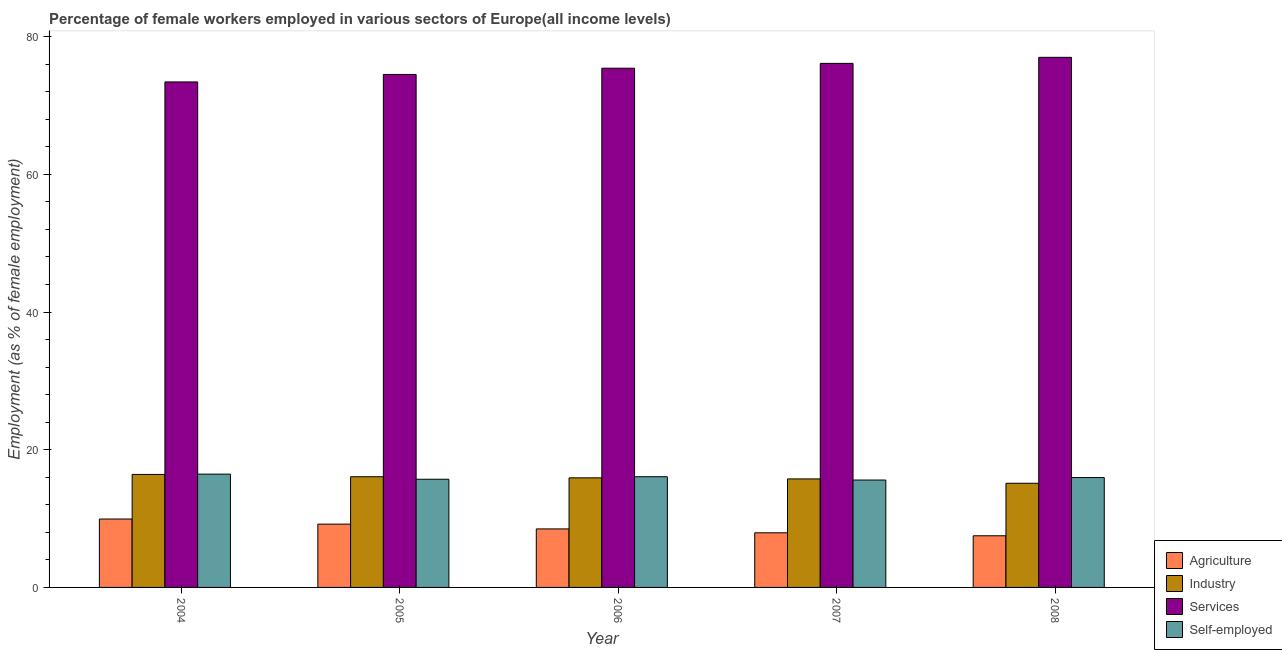How many different coloured bars are there?
Your answer should be compact. 4. How many groups of bars are there?
Provide a short and direct response. 5. Are the number of bars per tick equal to the number of legend labels?
Offer a terse response. Yes. Are the number of bars on each tick of the X-axis equal?
Ensure brevity in your answer.  Yes. What is the percentage of self employed female workers in 2006?
Provide a succinct answer. 16.08. Across all years, what is the maximum percentage of female workers in industry?
Provide a short and direct response. 16.41. Across all years, what is the minimum percentage of female workers in agriculture?
Provide a short and direct response. 7.5. In which year was the percentage of female workers in industry minimum?
Your response must be concise. 2008. What is the total percentage of female workers in agriculture in the graph?
Provide a succinct answer. 43.07. What is the difference between the percentage of self employed female workers in 2004 and that in 2005?
Keep it short and to the point. 0.74. What is the difference between the percentage of female workers in industry in 2005 and the percentage of female workers in agriculture in 2007?
Offer a very short reply. 0.32. What is the average percentage of female workers in agriculture per year?
Offer a terse response. 8.61. In how many years, is the percentage of self employed female workers greater than 40 %?
Your response must be concise. 0. What is the ratio of the percentage of female workers in industry in 2004 to that in 2005?
Ensure brevity in your answer.  1.02. Is the difference between the percentage of female workers in industry in 2005 and 2007 greater than the difference between the percentage of self employed female workers in 2005 and 2007?
Offer a terse response. No. What is the difference between the highest and the second highest percentage of female workers in services?
Ensure brevity in your answer.  0.88. What is the difference between the highest and the lowest percentage of female workers in agriculture?
Offer a terse response. 2.43. What does the 2nd bar from the left in 2008 represents?
Provide a succinct answer. Industry. What does the 2nd bar from the right in 2006 represents?
Provide a succinct answer. Services. Are all the bars in the graph horizontal?
Provide a short and direct response. No. How many years are there in the graph?
Keep it short and to the point. 5. What is the title of the graph?
Your response must be concise. Percentage of female workers employed in various sectors of Europe(all income levels). Does "Taxes on goods and services" appear as one of the legend labels in the graph?
Make the answer very short. No. What is the label or title of the Y-axis?
Provide a succinct answer. Employment (as % of female employment). What is the Employment (as % of female employment) in Agriculture in 2004?
Ensure brevity in your answer.  9.94. What is the Employment (as % of female employment) of Industry in 2004?
Your answer should be compact. 16.41. What is the Employment (as % of female employment) of Services in 2004?
Give a very brief answer. 73.43. What is the Employment (as % of female employment) of Self-employed in 2004?
Offer a terse response. 16.46. What is the Employment (as % of female employment) of Agriculture in 2005?
Ensure brevity in your answer.  9.19. What is the Employment (as % of female employment) of Industry in 2005?
Offer a very short reply. 16.08. What is the Employment (as % of female employment) of Services in 2005?
Offer a very short reply. 74.52. What is the Employment (as % of female employment) of Self-employed in 2005?
Your response must be concise. 15.72. What is the Employment (as % of female employment) of Agriculture in 2006?
Your response must be concise. 8.5. What is the Employment (as % of female employment) in Industry in 2006?
Give a very brief answer. 15.92. What is the Employment (as % of female employment) of Services in 2006?
Provide a short and direct response. 75.42. What is the Employment (as % of female employment) in Self-employed in 2006?
Your response must be concise. 16.08. What is the Employment (as % of female employment) of Agriculture in 2007?
Your answer should be compact. 7.93. What is the Employment (as % of female employment) of Industry in 2007?
Provide a succinct answer. 15.76. What is the Employment (as % of female employment) of Services in 2007?
Offer a very short reply. 76.13. What is the Employment (as % of female employment) of Self-employed in 2007?
Give a very brief answer. 15.6. What is the Employment (as % of female employment) in Agriculture in 2008?
Offer a very short reply. 7.5. What is the Employment (as % of female employment) in Industry in 2008?
Make the answer very short. 15.13. What is the Employment (as % of female employment) of Services in 2008?
Your response must be concise. 77. What is the Employment (as % of female employment) of Self-employed in 2008?
Make the answer very short. 15.96. Across all years, what is the maximum Employment (as % of female employment) in Agriculture?
Give a very brief answer. 9.94. Across all years, what is the maximum Employment (as % of female employment) of Industry?
Provide a succinct answer. 16.41. Across all years, what is the maximum Employment (as % of female employment) of Services?
Your response must be concise. 77. Across all years, what is the maximum Employment (as % of female employment) in Self-employed?
Keep it short and to the point. 16.46. Across all years, what is the minimum Employment (as % of female employment) in Agriculture?
Keep it short and to the point. 7.5. Across all years, what is the minimum Employment (as % of female employment) of Industry?
Make the answer very short. 15.13. Across all years, what is the minimum Employment (as % of female employment) of Services?
Provide a short and direct response. 73.43. Across all years, what is the minimum Employment (as % of female employment) of Self-employed?
Your answer should be compact. 15.6. What is the total Employment (as % of female employment) in Agriculture in the graph?
Make the answer very short. 43.07. What is the total Employment (as % of female employment) in Industry in the graph?
Make the answer very short. 79.31. What is the total Employment (as % of female employment) of Services in the graph?
Make the answer very short. 376.51. What is the total Employment (as % of female employment) in Self-employed in the graph?
Provide a short and direct response. 79.81. What is the difference between the Employment (as % of female employment) in Agriculture in 2004 and that in 2005?
Ensure brevity in your answer.  0.74. What is the difference between the Employment (as % of female employment) in Industry in 2004 and that in 2005?
Your answer should be very brief. 0.34. What is the difference between the Employment (as % of female employment) of Services in 2004 and that in 2005?
Ensure brevity in your answer.  -1.09. What is the difference between the Employment (as % of female employment) of Self-employed in 2004 and that in 2005?
Your answer should be compact. 0.74. What is the difference between the Employment (as % of female employment) of Agriculture in 2004 and that in 2006?
Give a very brief answer. 1.44. What is the difference between the Employment (as % of female employment) in Industry in 2004 and that in 2006?
Give a very brief answer. 0.5. What is the difference between the Employment (as % of female employment) of Services in 2004 and that in 2006?
Offer a terse response. -1.99. What is the difference between the Employment (as % of female employment) in Self-employed in 2004 and that in 2006?
Your response must be concise. 0.38. What is the difference between the Employment (as % of female employment) of Agriculture in 2004 and that in 2007?
Your answer should be compact. 2. What is the difference between the Employment (as % of female employment) of Industry in 2004 and that in 2007?
Ensure brevity in your answer.  0.65. What is the difference between the Employment (as % of female employment) of Services in 2004 and that in 2007?
Give a very brief answer. -2.69. What is the difference between the Employment (as % of female employment) of Self-employed in 2004 and that in 2007?
Your response must be concise. 0.86. What is the difference between the Employment (as % of female employment) of Agriculture in 2004 and that in 2008?
Offer a terse response. 2.43. What is the difference between the Employment (as % of female employment) in Industry in 2004 and that in 2008?
Offer a very short reply. 1.28. What is the difference between the Employment (as % of female employment) of Services in 2004 and that in 2008?
Your response must be concise. -3.57. What is the difference between the Employment (as % of female employment) in Self-employed in 2004 and that in 2008?
Keep it short and to the point. 0.5. What is the difference between the Employment (as % of female employment) in Agriculture in 2005 and that in 2006?
Your response must be concise. 0.69. What is the difference between the Employment (as % of female employment) in Industry in 2005 and that in 2006?
Keep it short and to the point. 0.16. What is the difference between the Employment (as % of female employment) in Services in 2005 and that in 2006?
Make the answer very short. -0.9. What is the difference between the Employment (as % of female employment) in Self-employed in 2005 and that in 2006?
Provide a succinct answer. -0.36. What is the difference between the Employment (as % of female employment) of Agriculture in 2005 and that in 2007?
Your answer should be compact. 1.26. What is the difference between the Employment (as % of female employment) in Industry in 2005 and that in 2007?
Ensure brevity in your answer.  0.32. What is the difference between the Employment (as % of female employment) of Services in 2005 and that in 2007?
Provide a short and direct response. -1.61. What is the difference between the Employment (as % of female employment) in Self-employed in 2005 and that in 2007?
Your answer should be very brief. 0.12. What is the difference between the Employment (as % of female employment) of Agriculture in 2005 and that in 2008?
Give a very brief answer. 1.69. What is the difference between the Employment (as % of female employment) of Industry in 2005 and that in 2008?
Make the answer very short. 0.95. What is the difference between the Employment (as % of female employment) in Services in 2005 and that in 2008?
Provide a short and direct response. -2.49. What is the difference between the Employment (as % of female employment) in Self-employed in 2005 and that in 2008?
Offer a very short reply. -0.24. What is the difference between the Employment (as % of female employment) in Agriculture in 2006 and that in 2007?
Your response must be concise. 0.57. What is the difference between the Employment (as % of female employment) of Industry in 2006 and that in 2007?
Your answer should be very brief. 0.16. What is the difference between the Employment (as % of female employment) in Services in 2006 and that in 2007?
Offer a very short reply. -0.7. What is the difference between the Employment (as % of female employment) of Self-employed in 2006 and that in 2007?
Your answer should be compact. 0.48. What is the difference between the Employment (as % of female employment) in Agriculture in 2006 and that in 2008?
Offer a very short reply. 1. What is the difference between the Employment (as % of female employment) in Industry in 2006 and that in 2008?
Give a very brief answer. 0.79. What is the difference between the Employment (as % of female employment) in Services in 2006 and that in 2008?
Ensure brevity in your answer.  -1.58. What is the difference between the Employment (as % of female employment) in Self-employed in 2006 and that in 2008?
Offer a terse response. 0.12. What is the difference between the Employment (as % of female employment) of Agriculture in 2007 and that in 2008?
Offer a terse response. 0.43. What is the difference between the Employment (as % of female employment) in Industry in 2007 and that in 2008?
Ensure brevity in your answer.  0.63. What is the difference between the Employment (as % of female employment) of Services in 2007 and that in 2008?
Your answer should be very brief. -0.88. What is the difference between the Employment (as % of female employment) of Self-employed in 2007 and that in 2008?
Ensure brevity in your answer.  -0.36. What is the difference between the Employment (as % of female employment) in Agriculture in 2004 and the Employment (as % of female employment) in Industry in 2005?
Your answer should be compact. -6.14. What is the difference between the Employment (as % of female employment) of Agriculture in 2004 and the Employment (as % of female employment) of Services in 2005?
Give a very brief answer. -64.58. What is the difference between the Employment (as % of female employment) in Agriculture in 2004 and the Employment (as % of female employment) in Self-employed in 2005?
Keep it short and to the point. -5.78. What is the difference between the Employment (as % of female employment) of Industry in 2004 and the Employment (as % of female employment) of Services in 2005?
Offer a very short reply. -58.1. What is the difference between the Employment (as % of female employment) of Industry in 2004 and the Employment (as % of female employment) of Self-employed in 2005?
Offer a terse response. 0.7. What is the difference between the Employment (as % of female employment) of Services in 2004 and the Employment (as % of female employment) of Self-employed in 2005?
Make the answer very short. 57.72. What is the difference between the Employment (as % of female employment) in Agriculture in 2004 and the Employment (as % of female employment) in Industry in 2006?
Provide a succinct answer. -5.98. What is the difference between the Employment (as % of female employment) of Agriculture in 2004 and the Employment (as % of female employment) of Services in 2006?
Your response must be concise. -65.49. What is the difference between the Employment (as % of female employment) of Agriculture in 2004 and the Employment (as % of female employment) of Self-employed in 2006?
Ensure brevity in your answer.  -6.14. What is the difference between the Employment (as % of female employment) of Industry in 2004 and the Employment (as % of female employment) of Services in 2006?
Give a very brief answer. -59.01. What is the difference between the Employment (as % of female employment) of Industry in 2004 and the Employment (as % of female employment) of Self-employed in 2006?
Your response must be concise. 0.33. What is the difference between the Employment (as % of female employment) in Services in 2004 and the Employment (as % of female employment) in Self-employed in 2006?
Make the answer very short. 57.35. What is the difference between the Employment (as % of female employment) in Agriculture in 2004 and the Employment (as % of female employment) in Industry in 2007?
Your answer should be very brief. -5.83. What is the difference between the Employment (as % of female employment) of Agriculture in 2004 and the Employment (as % of female employment) of Services in 2007?
Your answer should be very brief. -66.19. What is the difference between the Employment (as % of female employment) of Agriculture in 2004 and the Employment (as % of female employment) of Self-employed in 2007?
Offer a very short reply. -5.66. What is the difference between the Employment (as % of female employment) of Industry in 2004 and the Employment (as % of female employment) of Services in 2007?
Offer a terse response. -59.71. What is the difference between the Employment (as % of female employment) in Industry in 2004 and the Employment (as % of female employment) in Self-employed in 2007?
Your response must be concise. 0.82. What is the difference between the Employment (as % of female employment) of Services in 2004 and the Employment (as % of female employment) of Self-employed in 2007?
Your answer should be compact. 57.83. What is the difference between the Employment (as % of female employment) in Agriculture in 2004 and the Employment (as % of female employment) in Industry in 2008?
Your response must be concise. -5.2. What is the difference between the Employment (as % of female employment) in Agriculture in 2004 and the Employment (as % of female employment) in Services in 2008?
Provide a short and direct response. -67.07. What is the difference between the Employment (as % of female employment) in Agriculture in 2004 and the Employment (as % of female employment) in Self-employed in 2008?
Provide a short and direct response. -6.02. What is the difference between the Employment (as % of female employment) in Industry in 2004 and the Employment (as % of female employment) in Services in 2008?
Provide a succinct answer. -60.59. What is the difference between the Employment (as % of female employment) of Industry in 2004 and the Employment (as % of female employment) of Self-employed in 2008?
Ensure brevity in your answer.  0.45. What is the difference between the Employment (as % of female employment) in Services in 2004 and the Employment (as % of female employment) in Self-employed in 2008?
Ensure brevity in your answer.  57.47. What is the difference between the Employment (as % of female employment) in Agriculture in 2005 and the Employment (as % of female employment) in Industry in 2006?
Give a very brief answer. -6.72. What is the difference between the Employment (as % of female employment) of Agriculture in 2005 and the Employment (as % of female employment) of Services in 2006?
Provide a succinct answer. -66.23. What is the difference between the Employment (as % of female employment) of Agriculture in 2005 and the Employment (as % of female employment) of Self-employed in 2006?
Provide a short and direct response. -6.89. What is the difference between the Employment (as % of female employment) of Industry in 2005 and the Employment (as % of female employment) of Services in 2006?
Your answer should be very brief. -59.34. What is the difference between the Employment (as % of female employment) of Industry in 2005 and the Employment (as % of female employment) of Self-employed in 2006?
Provide a short and direct response. -0. What is the difference between the Employment (as % of female employment) of Services in 2005 and the Employment (as % of female employment) of Self-employed in 2006?
Provide a short and direct response. 58.44. What is the difference between the Employment (as % of female employment) in Agriculture in 2005 and the Employment (as % of female employment) in Industry in 2007?
Offer a very short reply. -6.57. What is the difference between the Employment (as % of female employment) in Agriculture in 2005 and the Employment (as % of female employment) in Services in 2007?
Give a very brief answer. -66.93. What is the difference between the Employment (as % of female employment) in Agriculture in 2005 and the Employment (as % of female employment) in Self-employed in 2007?
Make the answer very short. -6.4. What is the difference between the Employment (as % of female employment) in Industry in 2005 and the Employment (as % of female employment) in Services in 2007?
Your response must be concise. -60.05. What is the difference between the Employment (as % of female employment) of Industry in 2005 and the Employment (as % of female employment) of Self-employed in 2007?
Ensure brevity in your answer.  0.48. What is the difference between the Employment (as % of female employment) in Services in 2005 and the Employment (as % of female employment) in Self-employed in 2007?
Your answer should be compact. 58.92. What is the difference between the Employment (as % of female employment) in Agriculture in 2005 and the Employment (as % of female employment) in Industry in 2008?
Offer a terse response. -5.94. What is the difference between the Employment (as % of female employment) in Agriculture in 2005 and the Employment (as % of female employment) in Services in 2008?
Provide a succinct answer. -67.81. What is the difference between the Employment (as % of female employment) in Agriculture in 2005 and the Employment (as % of female employment) in Self-employed in 2008?
Provide a succinct answer. -6.77. What is the difference between the Employment (as % of female employment) of Industry in 2005 and the Employment (as % of female employment) of Services in 2008?
Your response must be concise. -60.93. What is the difference between the Employment (as % of female employment) in Industry in 2005 and the Employment (as % of female employment) in Self-employed in 2008?
Keep it short and to the point. 0.12. What is the difference between the Employment (as % of female employment) of Services in 2005 and the Employment (as % of female employment) of Self-employed in 2008?
Your response must be concise. 58.56. What is the difference between the Employment (as % of female employment) of Agriculture in 2006 and the Employment (as % of female employment) of Industry in 2007?
Offer a terse response. -7.26. What is the difference between the Employment (as % of female employment) of Agriculture in 2006 and the Employment (as % of female employment) of Services in 2007?
Provide a short and direct response. -67.62. What is the difference between the Employment (as % of female employment) in Agriculture in 2006 and the Employment (as % of female employment) in Self-employed in 2007?
Give a very brief answer. -7.1. What is the difference between the Employment (as % of female employment) in Industry in 2006 and the Employment (as % of female employment) in Services in 2007?
Your answer should be compact. -60.21. What is the difference between the Employment (as % of female employment) of Industry in 2006 and the Employment (as % of female employment) of Self-employed in 2007?
Your answer should be very brief. 0.32. What is the difference between the Employment (as % of female employment) in Services in 2006 and the Employment (as % of female employment) in Self-employed in 2007?
Provide a succinct answer. 59.82. What is the difference between the Employment (as % of female employment) in Agriculture in 2006 and the Employment (as % of female employment) in Industry in 2008?
Give a very brief answer. -6.63. What is the difference between the Employment (as % of female employment) in Agriculture in 2006 and the Employment (as % of female employment) in Services in 2008?
Your answer should be compact. -68.5. What is the difference between the Employment (as % of female employment) of Agriculture in 2006 and the Employment (as % of female employment) of Self-employed in 2008?
Your answer should be compact. -7.46. What is the difference between the Employment (as % of female employment) of Industry in 2006 and the Employment (as % of female employment) of Services in 2008?
Provide a succinct answer. -61.09. What is the difference between the Employment (as % of female employment) of Industry in 2006 and the Employment (as % of female employment) of Self-employed in 2008?
Your response must be concise. -0.04. What is the difference between the Employment (as % of female employment) of Services in 2006 and the Employment (as % of female employment) of Self-employed in 2008?
Your response must be concise. 59.46. What is the difference between the Employment (as % of female employment) of Agriculture in 2007 and the Employment (as % of female employment) of Industry in 2008?
Give a very brief answer. -7.2. What is the difference between the Employment (as % of female employment) in Agriculture in 2007 and the Employment (as % of female employment) in Services in 2008?
Provide a succinct answer. -69.07. What is the difference between the Employment (as % of female employment) in Agriculture in 2007 and the Employment (as % of female employment) in Self-employed in 2008?
Offer a terse response. -8.03. What is the difference between the Employment (as % of female employment) of Industry in 2007 and the Employment (as % of female employment) of Services in 2008?
Offer a very short reply. -61.24. What is the difference between the Employment (as % of female employment) in Industry in 2007 and the Employment (as % of female employment) in Self-employed in 2008?
Make the answer very short. -0.2. What is the difference between the Employment (as % of female employment) of Services in 2007 and the Employment (as % of female employment) of Self-employed in 2008?
Provide a short and direct response. 60.17. What is the average Employment (as % of female employment) in Agriculture per year?
Make the answer very short. 8.61. What is the average Employment (as % of female employment) in Industry per year?
Make the answer very short. 15.86. What is the average Employment (as % of female employment) of Services per year?
Your response must be concise. 75.3. What is the average Employment (as % of female employment) of Self-employed per year?
Your answer should be very brief. 15.96. In the year 2004, what is the difference between the Employment (as % of female employment) of Agriculture and Employment (as % of female employment) of Industry?
Make the answer very short. -6.48. In the year 2004, what is the difference between the Employment (as % of female employment) in Agriculture and Employment (as % of female employment) in Services?
Keep it short and to the point. -63.49. In the year 2004, what is the difference between the Employment (as % of female employment) in Agriculture and Employment (as % of female employment) in Self-employed?
Make the answer very short. -6.52. In the year 2004, what is the difference between the Employment (as % of female employment) in Industry and Employment (as % of female employment) in Services?
Make the answer very short. -57.02. In the year 2004, what is the difference between the Employment (as % of female employment) in Industry and Employment (as % of female employment) in Self-employed?
Give a very brief answer. -0.04. In the year 2004, what is the difference between the Employment (as % of female employment) of Services and Employment (as % of female employment) of Self-employed?
Give a very brief answer. 56.97. In the year 2005, what is the difference between the Employment (as % of female employment) of Agriculture and Employment (as % of female employment) of Industry?
Offer a terse response. -6.88. In the year 2005, what is the difference between the Employment (as % of female employment) in Agriculture and Employment (as % of female employment) in Services?
Your answer should be very brief. -65.33. In the year 2005, what is the difference between the Employment (as % of female employment) in Agriculture and Employment (as % of female employment) in Self-employed?
Your answer should be compact. -6.52. In the year 2005, what is the difference between the Employment (as % of female employment) in Industry and Employment (as % of female employment) in Services?
Ensure brevity in your answer.  -58.44. In the year 2005, what is the difference between the Employment (as % of female employment) in Industry and Employment (as % of female employment) in Self-employed?
Ensure brevity in your answer.  0.36. In the year 2005, what is the difference between the Employment (as % of female employment) of Services and Employment (as % of female employment) of Self-employed?
Offer a terse response. 58.8. In the year 2006, what is the difference between the Employment (as % of female employment) of Agriculture and Employment (as % of female employment) of Industry?
Offer a very short reply. -7.42. In the year 2006, what is the difference between the Employment (as % of female employment) in Agriculture and Employment (as % of female employment) in Services?
Your response must be concise. -66.92. In the year 2006, what is the difference between the Employment (as % of female employment) of Agriculture and Employment (as % of female employment) of Self-employed?
Offer a terse response. -7.58. In the year 2006, what is the difference between the Employment (as % of female employment) of Industry and Employment (as % of female employment) of Services?
Provide a succinct answer. -59.5. In the year 2006, what is the difference between the Employment (as % of female employment) of Industry and Employment (as % of female employment) of Self-employed?
Offer a terse response. -0.16. In the year 2006, what is the difference between the Employment (as % of female employment) in Services and Employment (as % of female employment) in Self-employed?
Keep it short and to the point. 59.34. In the year 2007, what is the difference between the Employment (as % of female employment) of Agriculture and Employment (as % of female employment) of Industry?
Make the answer very short. -7.83. In the year 2007, what is the difference between the Employment (as % of female employment) of Agriculture and Employment (as % of female employment) of Services?
Keep it short and to the point. -68.19. In the year 2007, what is the difference between the Employment (as % of female employment) of Agriculture and Employment (as % of female employment) of Self-employed?
Offer a very short reply. -7.67. In the year 2007, what is the difference between the Employment (as % of female employment) in Industry and Employment (as % of female employment) in Services?
Your answer should be very brief. -60.36. In the year 2007, what is the difference between the Employment (as % of female employment) of Industry and Employment (as % of female employment) of Self-employed?
Give a very brief answer. 0.16. In the year 2007, what is the difference between the Employment (as % of female employment) in Services and Employment (as % of female employment) in Self-employed?
Offer a terse response. 60.53. In the year 2008, what is the difference between the Employment (as % of female employment) of Agriculture and Employment (as % of female employment) of Industry?
Your answer should be compact. -7.63. In the year 2008, what is the difference between the Employment (as % of female employment) of Agriculture and Employment (as % of female employment) of Services?
Ensure brevity in your answer.  -69.5. In the year 2008, what is the difference between the Employment (as % of female employment) of Agriculture and Employment (as % of female employment) of Self-employed?
Give a very brief answer. -8.46. In the year 2008, what is the difference between the Employment (as % of female employment) in Industry and Employment (as % of female employment) in Services?
Ensure brevity in your answer.  -61.87. In the year 2008, what is the difference between the Employment (as % of female employment) in Industry and Employment (as % of female employment) in Self-employed?
Offer a very short reply. -0.83. In the year 2008, what is the difference between the Employment (as % of female employment) in Services and Employment (as % of female employment) in Self-employed?
Your answer should be compact. 61.05. What is the ratio of the Employment (as % of female employment) of Agriculture in 2004 to that in 2005?
Provide a short and direct response. 1.08. What is the ratio of the Employment (as % of female employment) in Industry in 2004 to that in 2005?
Ensure brevity in your answer.  1.02. What is the ratio of the Employment (as % of female employment) in Services in 2004 to that in 2005?
Your response must be concise. 0.99. What is the ratio of the Employment (as % of female employment) in Self-employed in 2004 to that in 2005?
Offer a terse response. 1.05. What is the ratio of the Employment (as % of female employment) in Agriculture in 2004 to that in 2006?
Your response must be concise. 1.17. What is the ratio of the Employment (as % of female employment) in Industry in 2004 to that in 2006?
Give a very brief answer. 1.03. What is the ratio of the Employment (as % of female employment) in Services in 2004 to that in 2006?
Offer a very short reply. 0.97. What is the ratio of the Employment (as % of female employment) in Self-employed in 2004 to that in 2006?
Offer a terse response. 1.02. What is the ratio of the Employment (as % of female employment) of Agriculture in 2004 to that in 2007?
Your answer should be very brief. 1.25. What is the ratio of the Employment (as % of female employment) of Industry in 2004 to that in 2007?
Provide a succinct answer. 1.04. What is the ratio of the Employment (as % of female employment) of Services in 2004 to that in 2007?
Offer a terse response. 0.96. What is the ratio of the Employment (as % of female employment) in Self-employed in 2004 to that in 2007?
Give a very brief answer. 1.05. What is the ratio of the Employment (as % of female employment) in Agriculture in 2004 to that in 2008?
Offer a very short reply. 1.32. What is the ratio of the Employment (as % of female employment) in Industry in 2004 to that in 2008?
Offer a very short reply. 1.08. What is the ratio of the Employment (as % of female employment) of Services in 2004 to that in 2008?
Your answer should be very brief. 0.95. What is the ratio of the Employment (as % of female employment) of Self-employed in 2004 to that in 2008?
Provide a short and direct response. 1.03. What is the ratio of the Employment (as % of female employment) in Agriculture in 2005 to that in 2006?
Make the answer very short. 1.08. What is the ratio of the Employment (as % of female employment) in Industry in 2005 to that in 2006?
Your response must be concise. 1.01. What is the ratio of the Employment (as % of female employment) of Services in 2005 to that in 2006?
Keep it short and to the point. 0.99. What is the ratio of the Employment (as % of female employment) in Self-employed in 2005 to that in 2006?
Your response must be concise. 0.98. What is the ratio of the Employment (as % of female employment) of Agriculture in 2005 to that in 2007?
Your answer should be compact. 1.16. What is the ratio of the Employment (as % of female employment) in Industry in 2005 to that in 2007?
Ensure brevity in your answer.  1.02. What is the ratio of the Employment (as % of female employment) in Services in 2005 to that in 2007?
Give a very brief answer. 0.98. What is the ratio of the Employment (as % of female employment) of Self-employed in 2005 to that in 2007?
Provide a succinct answer. 1.01. What is the ratio of the Employment (as % of female employment) of Agriculture in 2005 to that in 2008?
Provide a short and direct response. 1.23. What is the ratio of the Employment (as % of female employment) of Industry in 2005 to that in 2008?
Offer a terse response. 1.06. What is the ratio of the Employment (as % of female employment) of Self-employed in 2005 to that in 2008?
Keep it short and to the point. 0.98. What is the ratio of the Employment (as % of female employment) of Agriculture in 2006 to that in 2007?
Give a very brief answer. 1.07. What is the ratio of the Employment (as % of female employment) in Industry in 2006 to that in 2007?
Provide a succinct answer. 1.01. What is the ratio of the Employment (as % of female employment) in Services in 2006 to that in 2007?
Provide a succinct answer. 0.99. What is the ratio of the Employment (as % of female employment) in Self-employed in 2006 to that in 2007?
Your answer should be very brief. 1.03. What is the ratio of the Employment (as % of female employment) of Agriculture in 2006 to that in 2008?
Your response must be concise. 1.13. What is the ratio of the Employment (as % of female employment) of Industry in 2006 to that in 2008?
Make the answer very short. 1.05. What is the ratio of the Employment (as % of female employment) in Services in 2006 to that in 2008?
Provide a succinct answer. 0.98. What is the ratio of the Employment (as % of female employment) of Self-employed in 2006 to that in 2008?
Give a very brief answer. 1.01. What is the ratio of the Employment (as % of female employment) in Agriculture in 2007 to that in 2008?
Offer a terse response. 1.06. What is the ratio of the Employment (as % of female employment) in Industry in 2007 to that in 2008?
Provide a short and direct response. 1.04. What is the ratio of the Employment (as % of female employment) in Self-employed in 2007 to that in 2008?
Offer a very short reply. 0.98. What is the difference between the highest and the second highest Employment (as % of female employment) in Agriculture?
Keep it short and to the point. 0.74. What is the difference between the highest and the second highest Employment (as % of female employment) in Industry?
Provide a short and direct response. 0.34. What is the difference between the highest and the second highest Employment (as % of female employment) in Services?
Ensure brevity in your answer.  0.88. What is the difference between the highest and the second highest Employment (as % of female employment) of Self-employed?
Offer a very short reply. 0.38. What is the difference between the highest and the lowest Employment (as % of female employment) in Agriculture?
Your answer should be very brief. 2.43. What is the difference between the highest and the lowest Employment (as % of female employment) of Industry?
Offer a terse response. 1.28. What is the difference between the highest and the lowest Employment (as % of female employment) of Services?
Ensure brevity in your answer.  3.57. What is the difference between the highest and the lowest Employment (as % of female employment) in Self-employed?
Provide a succinct answer. 0.86. 